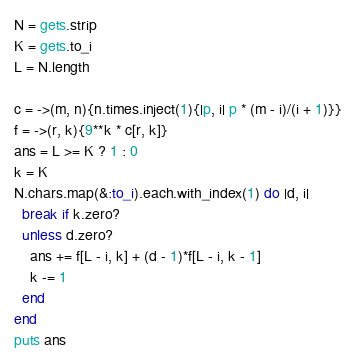Convert code to text. <code><loc_0><loc_0><loc_500><loc_500><_Ruby_>N = gets.strip
K = gets.to_i
L = N.length

c = ->(m, n){n.times.inject(1){|p, i| p * (m - i)/(i + 1)}}
f = ->(r, k){9**k * c[r, k]}
ans = L >= K ? 1 : 0
k = K
N.chars.map(&:to_i).each.with_index(1) do |d, i|
  break if k.zero?
  unless d.zero?
    ans += f[L - i, k] + (d - 1)*f[L - i, k - 1]
    k -= 1
  end
end
puts ans</code> 